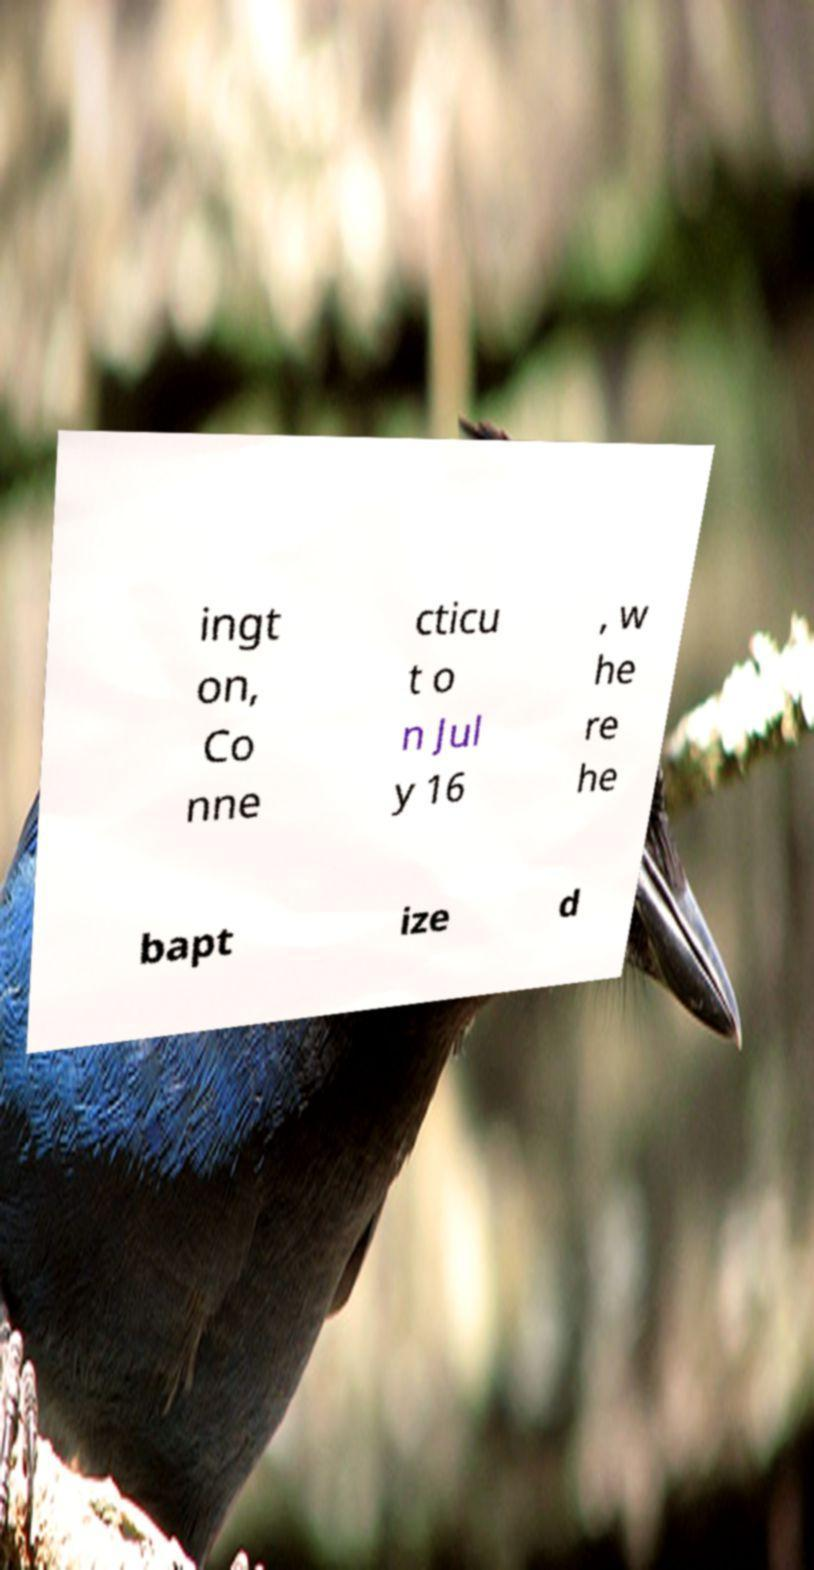What messages or text are displayed in this image? I need them in a readable, typed format. ingt on, Co nne cticu t o n Jul y 16 , w he re he bapt ize d 